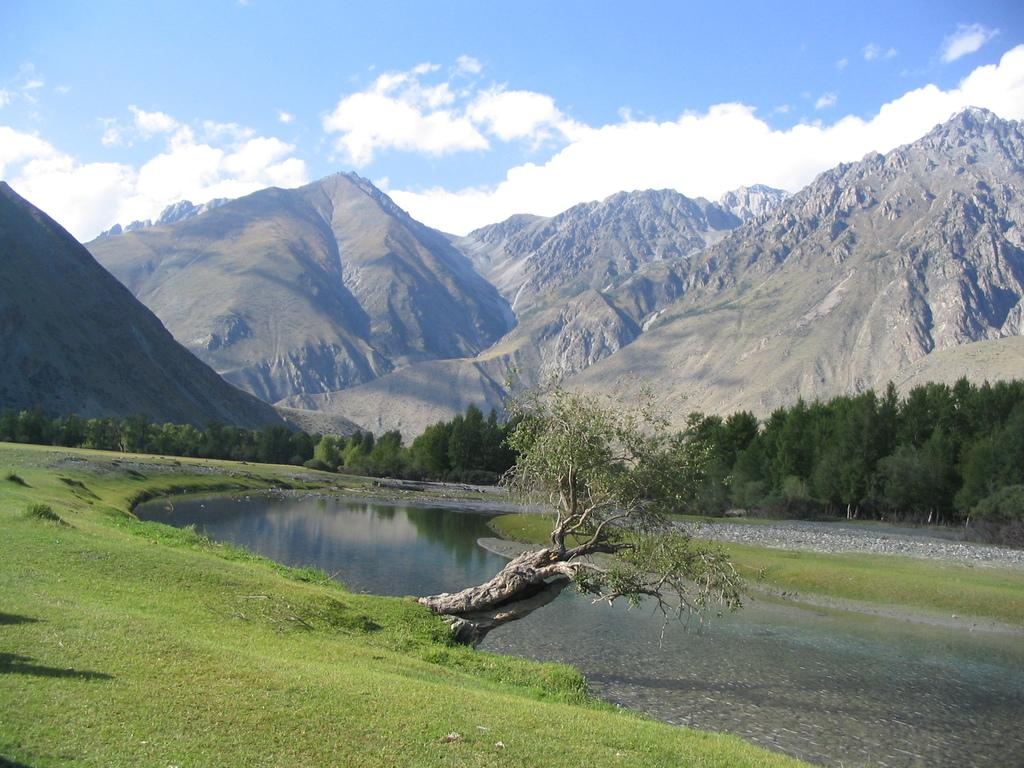What type of natural landscape is depicted in the image? The image features mountains, trees, grass, and water, indicating a natural landscape. Can you describe the vegetation in the image? There are trees and grass visible in the image. What is the condition of the sky in the image? The sky is cloudy in the image. Is there any water visible in the image? Yes, there is water visible in the image. What type of collar can be seen on the bear in the image? There is no bear present in the image, so there is no collar to be seen. 